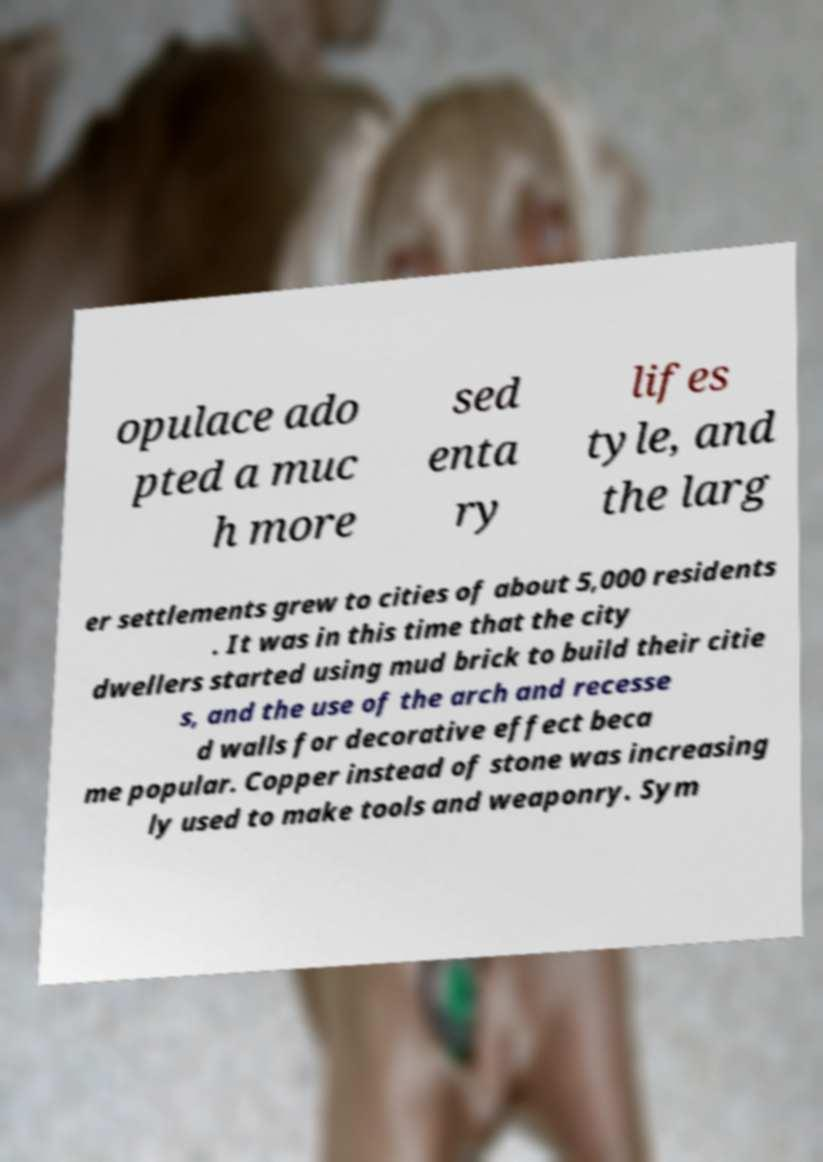Can you read and provide the text displayed in the image?This photo seems to have some interesting text. Can you extract and type it out for me? opulace ado pted a muc h more sed enta ry lifes tyle, and the larg er settlements grew to cities of about 5,000 residents . It was in this time that the city dwellers started using mud brick to build their citie s, and the use of the arch and recesse d walls for decorative effect beca me popular. Copper instead of stone was increasing ly used to make tools and weaponry. Sym 